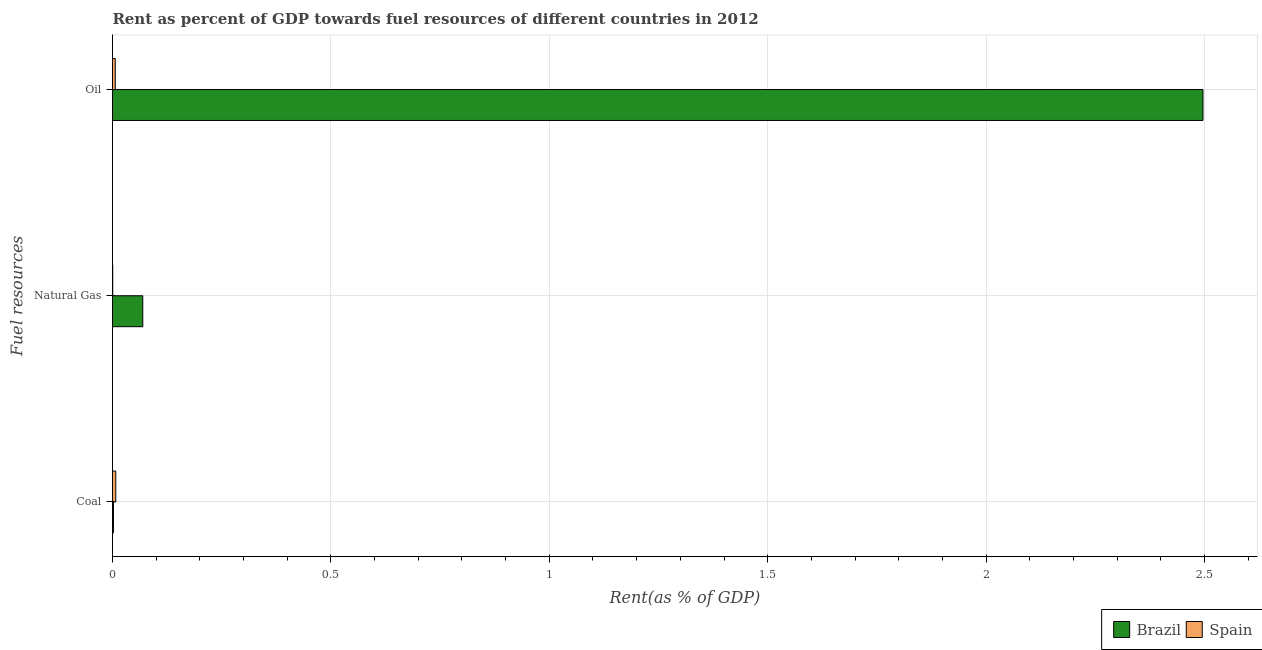How many different coloured bars are there?
Your answer should be very brief. 2. Are the number of bars per tick equal to the number of legend labels?
Your answer should be very brief. Yes. Are the number of bars on each tick of the Y-axis equal?
Provide a short and direct response. Yes. How many bars are there on the 3rd tick from the top?
Your response must be concise. 2. How many bars are there on the 3rd tick from the bottom?
Provide a succinct answer. 2. What is the label of the 1st group of bars from the top?
Your answer should be compact. Oil. What is the rent towards oil in Brazil?
Provide a short and direct response. 2.5. Across all countries, what is the maximum rent towards coal?
Keep it short and to the point. 0.01. Across all countries, what is the minimum rent towards natural gas?
Your answer should be very brief. 0. In which country was the rent towards oil maximum?
Make the answer very short. Brazil. What is the total rent towards coal in the graph?
Ensure brevity in your answer.  0.01. What is the difference between the rent towards natural gas in Spain and that in Brazil?
Provide a short and direct response. -0.07. What is the difference between the rent towards coal in Spain and the rent towards natural gas in Brazil?
Offer a terse response. -0.06. What is the average rent towards oil per country?
Ensure brevity in your answer.  1.25. What is the difference between the rent towards natural gas and rent towards coal in Brazil?
Your answer should be compact. 0.07. In how many countries, is the rent towards oil greater than 2.2 %?
Make the answer very short. 1. What is the ratio of the rent towards oil in Spain to that in Brazil?
Your answer should be very brief. 0. What is the difference between the highest and the second highest rent towards natural gas?
Keep it short and to the point. 0.07. What is the difference between the highest and the lowest rent towards coal?
Your answer should be very brief. 0.01. Is the sum of the rent towards coal in Spain and Brazil greater than the maximum rent towards oil across all countries?
Your answer should be compact. No. What does the 1st bar from the bottom in Natural Gas represents?
Ensure brevity in your answer.  Brazil. How many bars are there?
Offer a very short reply. 6. How many countries are there in the graph?
Offer a very short reply. 2. What is the difference between two consecutive major ticks on the X-axis?
Your response must be concise. 0.5. Does the graph contain grids?
Provide a succinct answer. Yes. Where does the legend appear in the graph?
Give a very brief answer. Bottom right. How many legend labels are there?
Provide a succinct answer. 2. What is the title of the graph?
Keep it short and to the point. Rent as percent of GDP towards fuel resources of different countries in 2012. What is the label or title of the X-axis?
Make the answer very short. Rent(as % of GDP). What is the label or title of the Y-axis?
Ensure brevity in your answer.  Fuel resources. What is the Rent(as % of GDP) of Brazil in Coal?
Provide a short and direct response. 0. What is the Rent(as % of GDP) in Spain in Coal?
Keep it short and to the point. 0.01. What is the Rent(as % of GDP) of Brazil in Natural Gas?
Offer a terse response. 0.07. What is the Rent(as % of GDP) of Spain in Natural Gas?
Make the answer very short. 0. What is the Rent(as % of GDP) in Brazil in Oil?
Your response must be concise. 2.5. What is the Rent(as % of GDP) in Spain in Oil?
Ensure brevity in your answer.  0.01. Across all Fuel resources, what is the maximum Rent(as % of GDP) of Brazil?
Ensure brevity in your answer.  2.5. Across all Fuel resources, what is the maximum Rent(as % of GDP) in Spain?
Your answer should be very brief. 0.01. Across all Fuel resources, what is the minimum Rent(as % of GDP) of Brazil?
Give a very brief answer. 0. Across all Fuel resources, what is the minimum Rent(as % of GDP) of Spain?
Provide a succinct answer. 0. What is the total Rent(as % of GDP) in Brazil in the graph?
Offer a very short reply. 2.57. What is the total Rent(as % of GDP) of Spain in the graph?
Offer a terse response. 0.01. What is the difference between the Rent(as % of GDP) in Brazil in Coal and that in Natural Gas?
Offer a very short reply. -0.07. What is the difference between the Rent(as % of GDP) of Spain in Coal and that in Natural Gas?
Your response must be concise. 0.01. What is the difference between the Rent(as % of GDP) of Brazil in Coal and that in Oil?
Provide a short and direct response. -2.49. What is the difference between the Rent(as % of GDP) in Spain in Coal and that in Oil?
Offer a terse response. 0. What is the difference between the Rent(as % of GDP) of Brazil in Natural Gas and that in Oil?
Offer a very short reply. -2.43. What is the difference between the Rent(as % of GDP) of Spain in Natural Gas and that in Oil?
Your answer should be compact. -0.01. What is the difference between the Rent(as % of GDP) of Brazil in Coal and the Rent(as % of GDP) of Spain in Natural Gas?
Provide a short and direct response. 0. What is the difference between the Rent(as % of GDP) of Brazil in Coal and the Rent(as % of GDP) of Spain in Oil?
Offer a terse response. -0. What is the difference between the Rent(as % of GDP) of Brazil in Natural Gas and the Rent(as % of GDP) of Spain in Oil?
Your answer should be very brief. 0.06. What is the average Rent(as % of GDP) of Brazil per Fuel resources?
Your answer should be compact. 0.86. What is the average Rent(as % of GDP) of Spain per Fuel resources?
Offer a very short reply. 0. What is the difference between the Rent(as % of GDP) of Brazil and Rent(as % of GDP) of Spain in Coal?
Keep it short and to the point. -0.01. What is the difference between the Rent(as % of GDP) in Brazil and Rent(as % of GDP) in Spain in Natural Gas?
Provide a short and direct response. 0.07. What is the difference between the Rent(as % of GDP) in Brazil and Rent(as % of GDP) in Spain in Oil?
Make the answer very short. 2.49. What is the ratio of the Rent(as % of GDP) in Brazil in Coal to that in Natural Gas?
Offer a very short reply. 0.03. What is the ratio of the Rent(as % of GDP) of Spain in Coal to that in Natural Gas?
Your answer should be compact. 15.71. What is the ratio of the Rent(as % of GDP) of Brazil in Coal to that in Oil?
Give a very brief answer. 0. What is the ratio of the Rent(as % of GDP) of Spain in Coal to that in Oil?
Your answer should be very brief. 1.19. What is the ratio of the Rent(as % of GDP) in Brazil in Natural Gas to that in Oil?
Provide a succinct answer. 0.03. What is the ratio of the Rent(as % of GDP) of Spain in Natural Gas to that in Oil?
Make the answer very short. 0.08. What is the difference between the highest and the second highest Rent(as % of GDP) in Brazil?
Make the answer very short. 2.43. What is the difference between the highest and the second highest Rent(as % of GDP) in Spain?
Ensure brevity in your answer.  0. What is the difference between the highest and the lowest Rent(as % of GDP) in Brazil?
Keep it short and to the point. 2.49. What is the difference between the highest and the lowest Rent(as % of GDP) in Spain?
Ensure brevity in your answer.  0.01. 